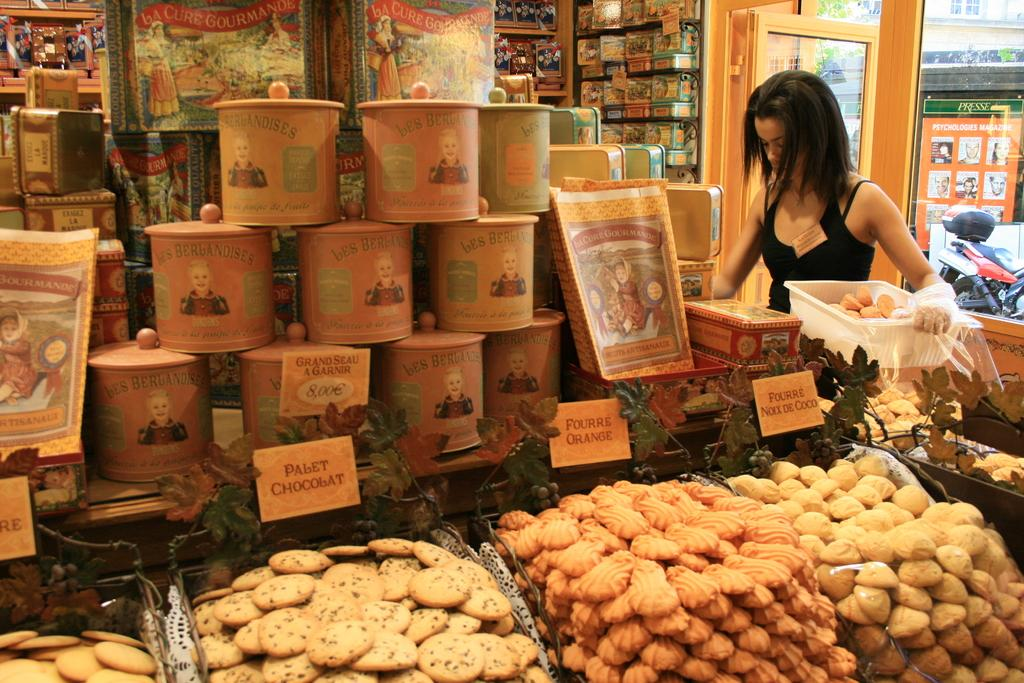Provide a one-sentence caption for the provided image. Pabet chocolat, fourre orange, and fourre Noxx de coco laid out in store. 